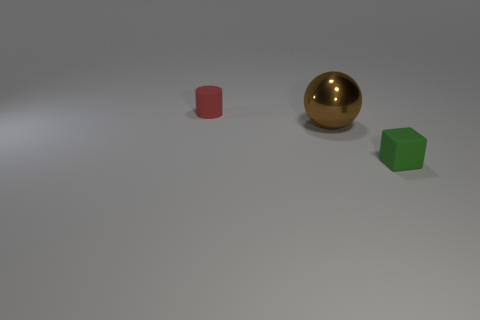Add 3 big metallic things. How many objects exist? 6 Subtract all spheres. How many objects are left? 2 Add 2 yellow rubber blocks. How many yellow rubber blocks exist? 2 Subtract 0 red blocks. How many objects are left? 3 Subtract all brown things. Subtract all metal objects. How many objects are left? 1 Add 1 red cylinders. How many red cylinders are left? 2 